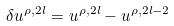Convert formula to latex. <formula><loc_0><loc_0><loc_500><loc_500>\delta u ^ { \rho , 2 l } = u ^ { \rho , 2 l } - u ^ { \rho , 2 l - 2 }</formula> 